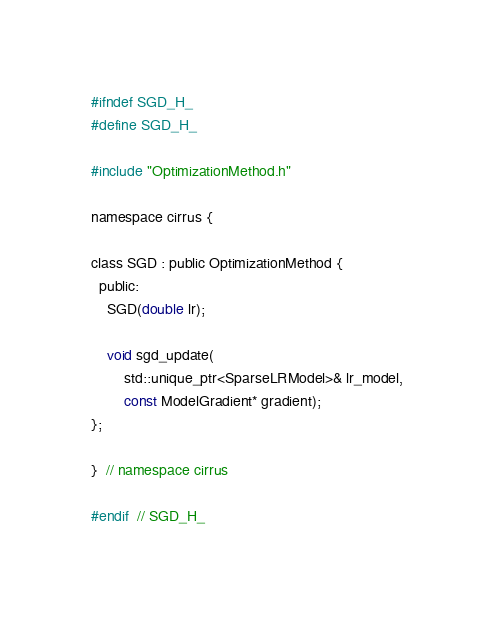Convert code to text. <code><loc_0><loc_0><loc_500><loc_500><_C_>#ifndef SGD_H_
#define SGD_H_

#include "OptimizationMethod.h"

namespace cirrus {

class SGD : public OptimizationMethod {
  public:
    SGD(double lr);

    void sgd_update(
        std::unique_ptr<SparseLRModel>& lr_model, 
        const ModelGradient* gradient);
};

}  // namespace cirrus

#endif  // SGD_H_
</code> 